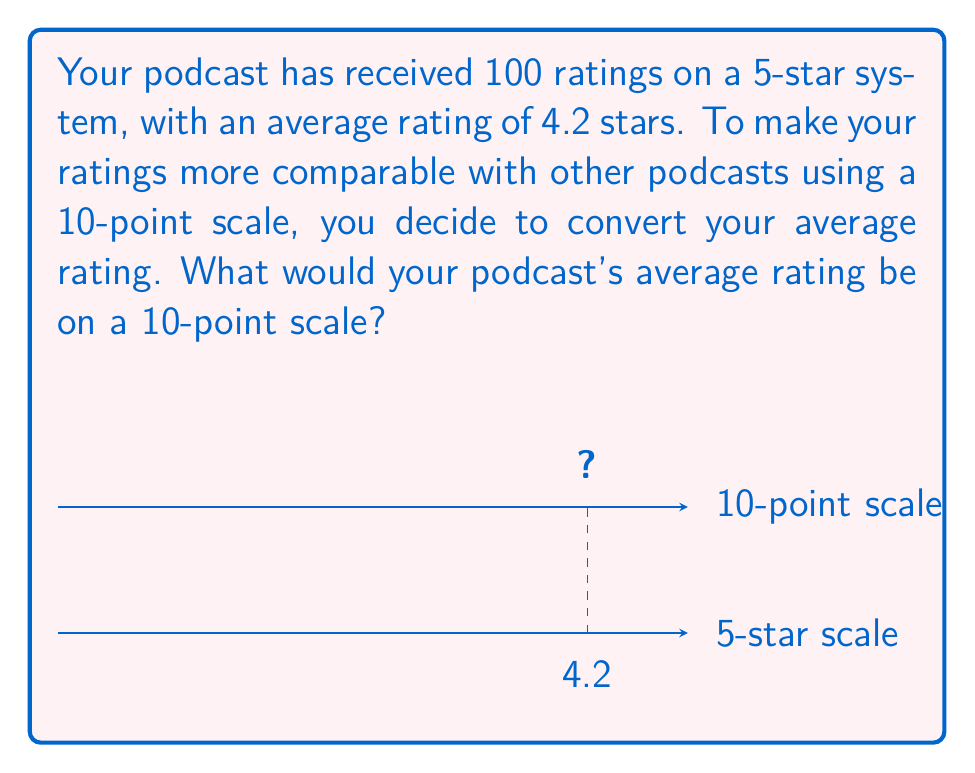Solve this math problem. To convert a rating from a 5-star system to a 10-point scale, we need to use proportional scaling. Here's how we can do it step-by-step:

1) First, let's set up a proportion:
   $$\frac{\text{5-star rating}}{\text{5 (max stars)}} = \frac{\text{10-point rating}}{\text{10 (max points)}}$$

2) We know the 5-star rating is 4.2, so let's plug that in:
   $$\frac{4.2}{5} = \frac{x}{10}$$

3) To solve for $x$, we can cross-multiply:
   $$4.2 \cdot 10 = 5x$$

4) Simplify the left side:
   $$42 = 5x$$

5) Divide both sides by 5:
   $$\frac{42}{5} = x$$

6) Simplify:
   $$8.4 = x$$

Therefore, a 4.2 rating on a 5-star system is equivalent to 8.4 on a 10-point scale.
Answer: 8.4 